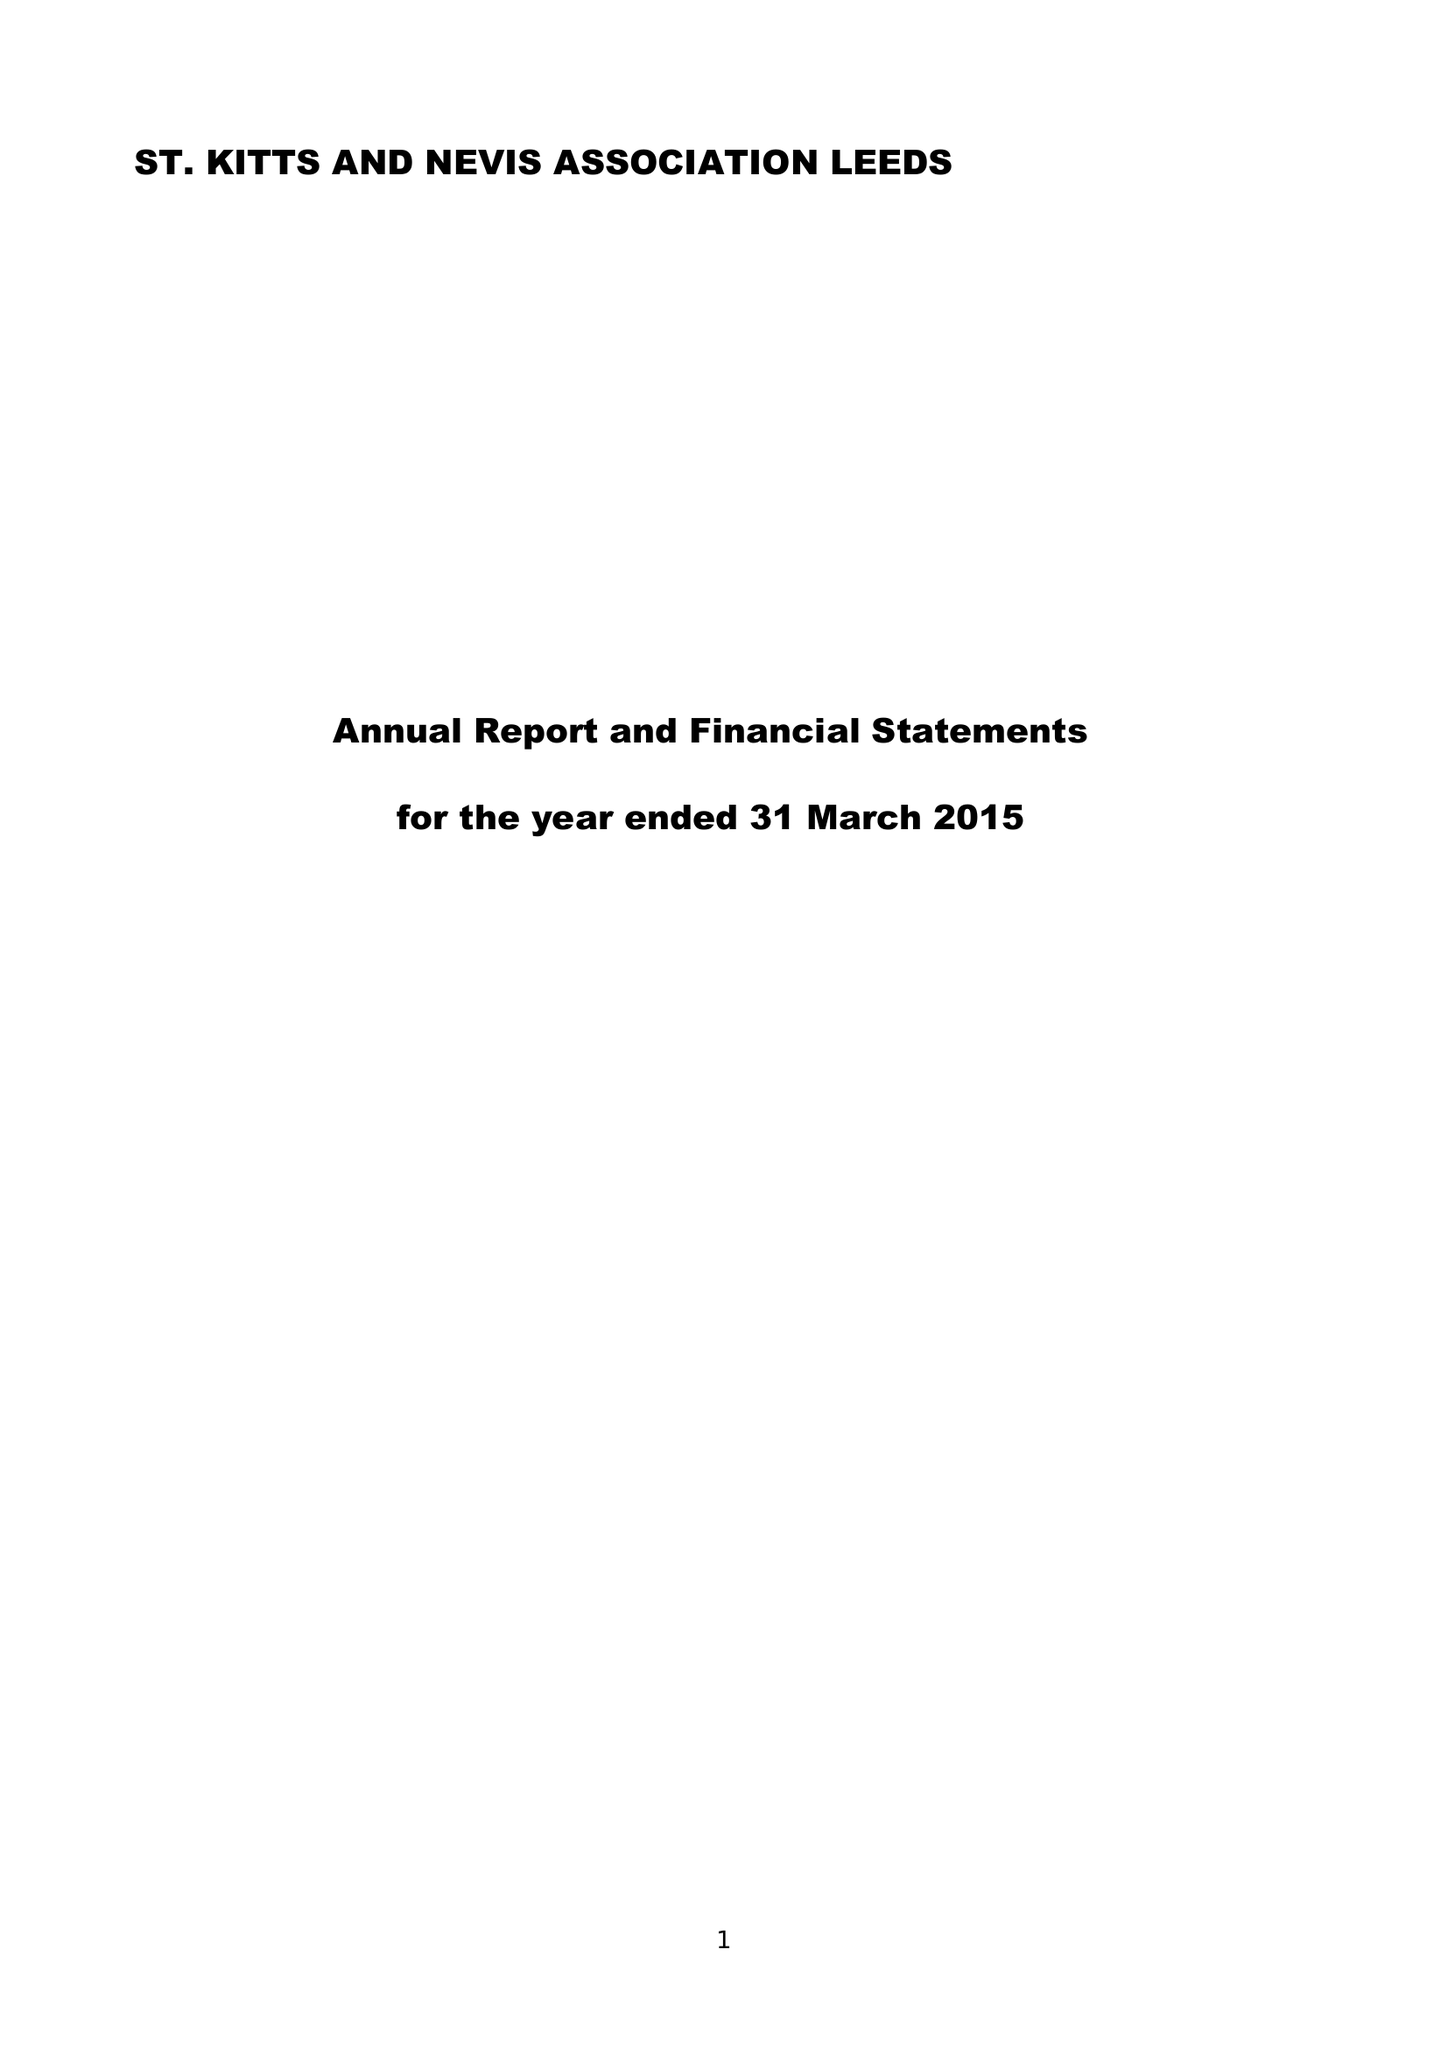What is the value for the income_annually_in_british_pounds?
Answer the question using a single word or phrase. 27088.00 